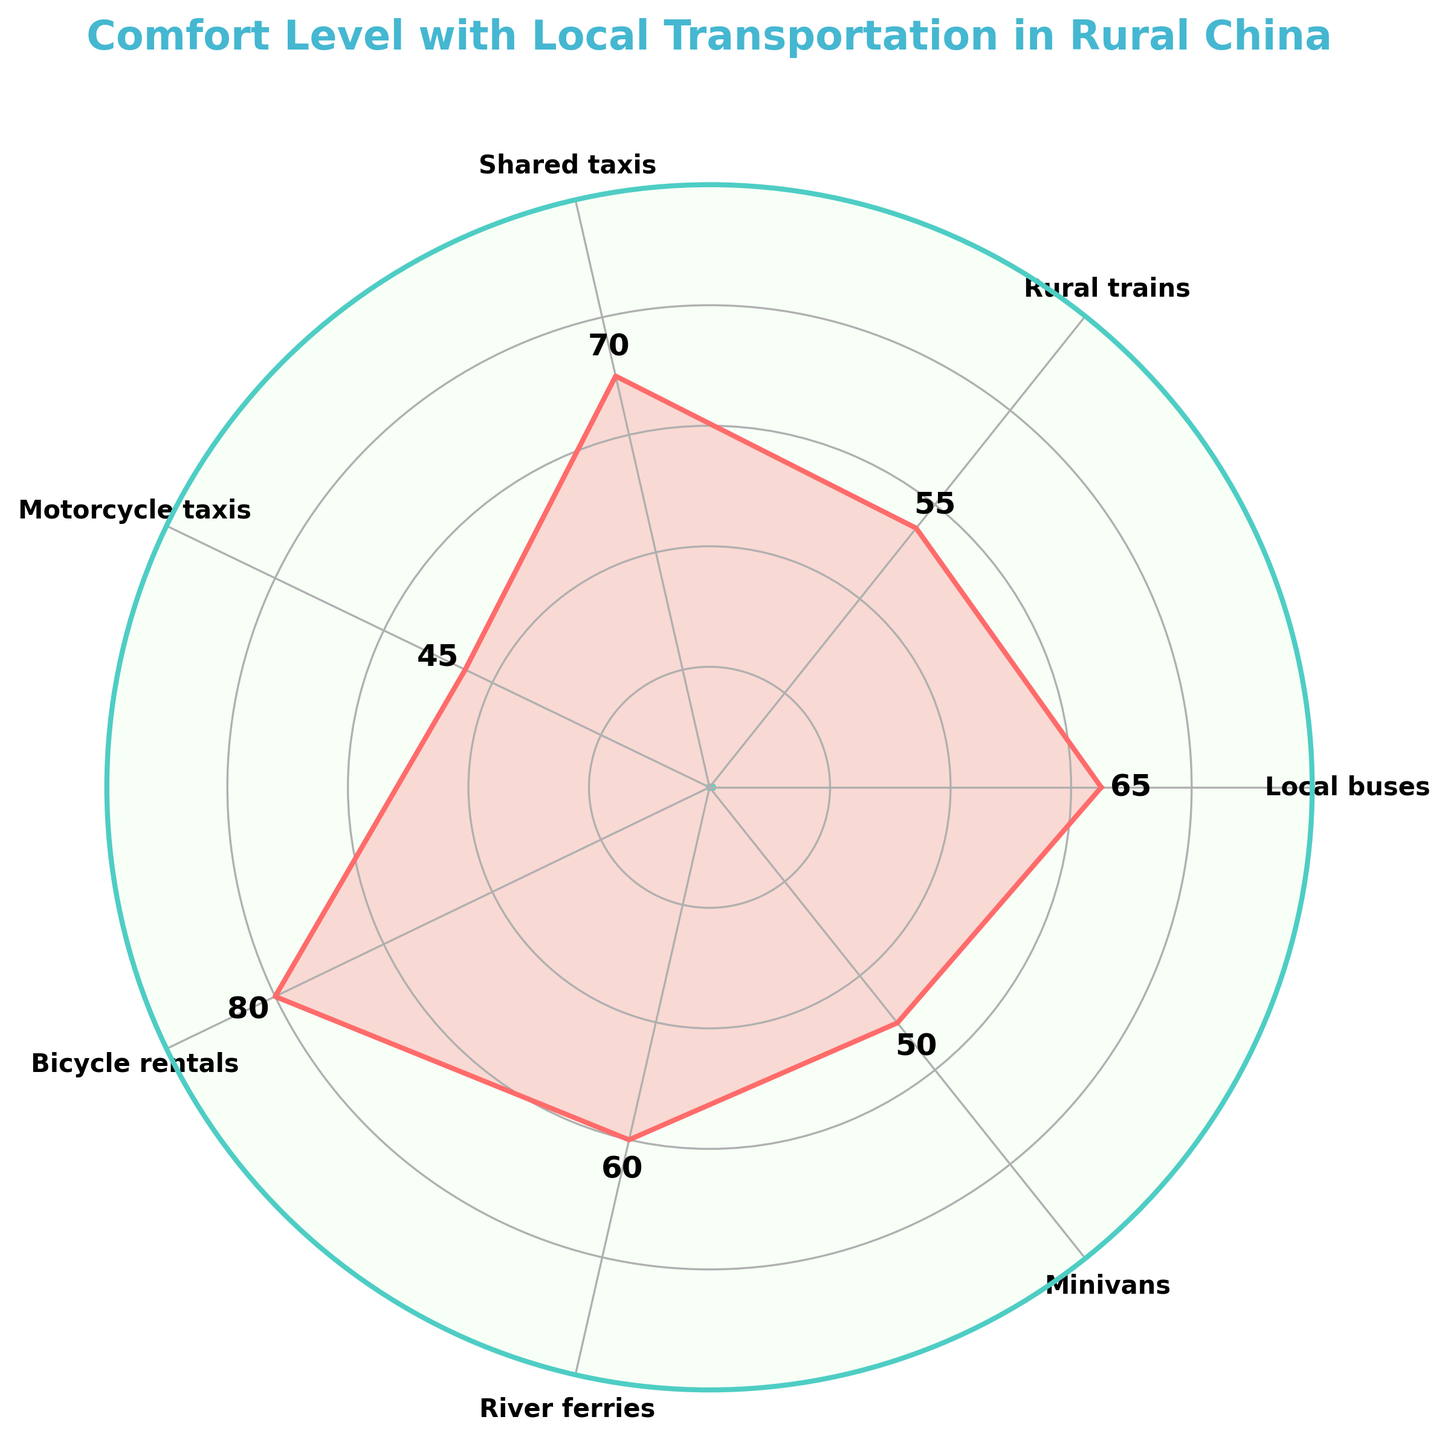How many local transportation methods are evaluated for comfort level? The plot evaluates the comfort level for seven different local transportation methods. You can count the labels on the gauge chart for this information.
Answer: Seven What is the title of the figure? The title is displayed at the top of the figure. It reads "Comfort Level with Local Transportation in Rural China."
Answer: Comfort Level with Local Transportation in Rural China Which local transportation method has the highest comfort level? The segment corresponding to "Bicycle rentals" extends the furthest, indicating that it has the highest comfort level.
Answer: Bicycle rentals What is the comfort level value for Motorcycle taxis? You can find the comfort level value for "Motorcycle taxis" by looking at where its segment ends on the radial gauge. The label next to the segment shows the value as 45.
Answer: 45 What is the average comfort level value for all local transportation methods evaluated? First, sum the comfort levels of all methods: 65 (Local buses) + 55 (Rural trains) + 70 (Shared taxis) + 45 (Motorcycle taxis) + 80 (Bicycle rentals) + 60 (River ferries) + 50 (Minivans) = 425. Then divide by the number of methods (7): 425 / 7 = 60.71.
Answer: 60.71 Which transportation method has a comfort level value closest to 60? By inspecting the segments and their corresponding values, "River ferries" has a comfort level value of 60.
Answer: River ferries How much higher is the comfort level of Bicycle rentals compared to Minivans? The comfort level for "Bicycle rentals" is 80, and for "Minivans" it is 50. The difference is 80 - 50 = 30.
Answer: 30 Which transportation methods have a comfort level below 60? "Rural trains," "Motorcycle taxis," and "Minivans" have comfort levels of 55, 45, and 50 respectively, which are all below 60.
Answer: Rural trains, Motorcycle taxis, Minivans What is the median comfort level value of the transportation methods? To find the median, list the values in ascending order: 45, 50, 55, 60, 65, 70, 80. The median is the middle number in this ordered list, which is 60.
Answer: 60 Which transportation methods have a comfort level greater than 65? By reviewing the segments, "Shared taxis" and "Bicycle rentals" have comfort levels greater than 65, with values of 70 and 80 respectively.
Answer: Shared taxis, Bicycle rentals 